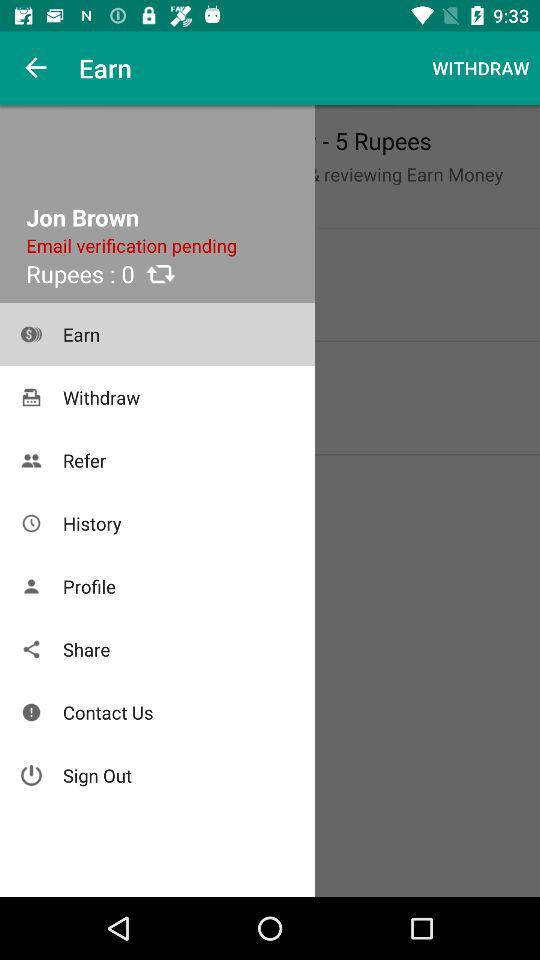How many rupees are displayed? The displayed rupee is 0. 